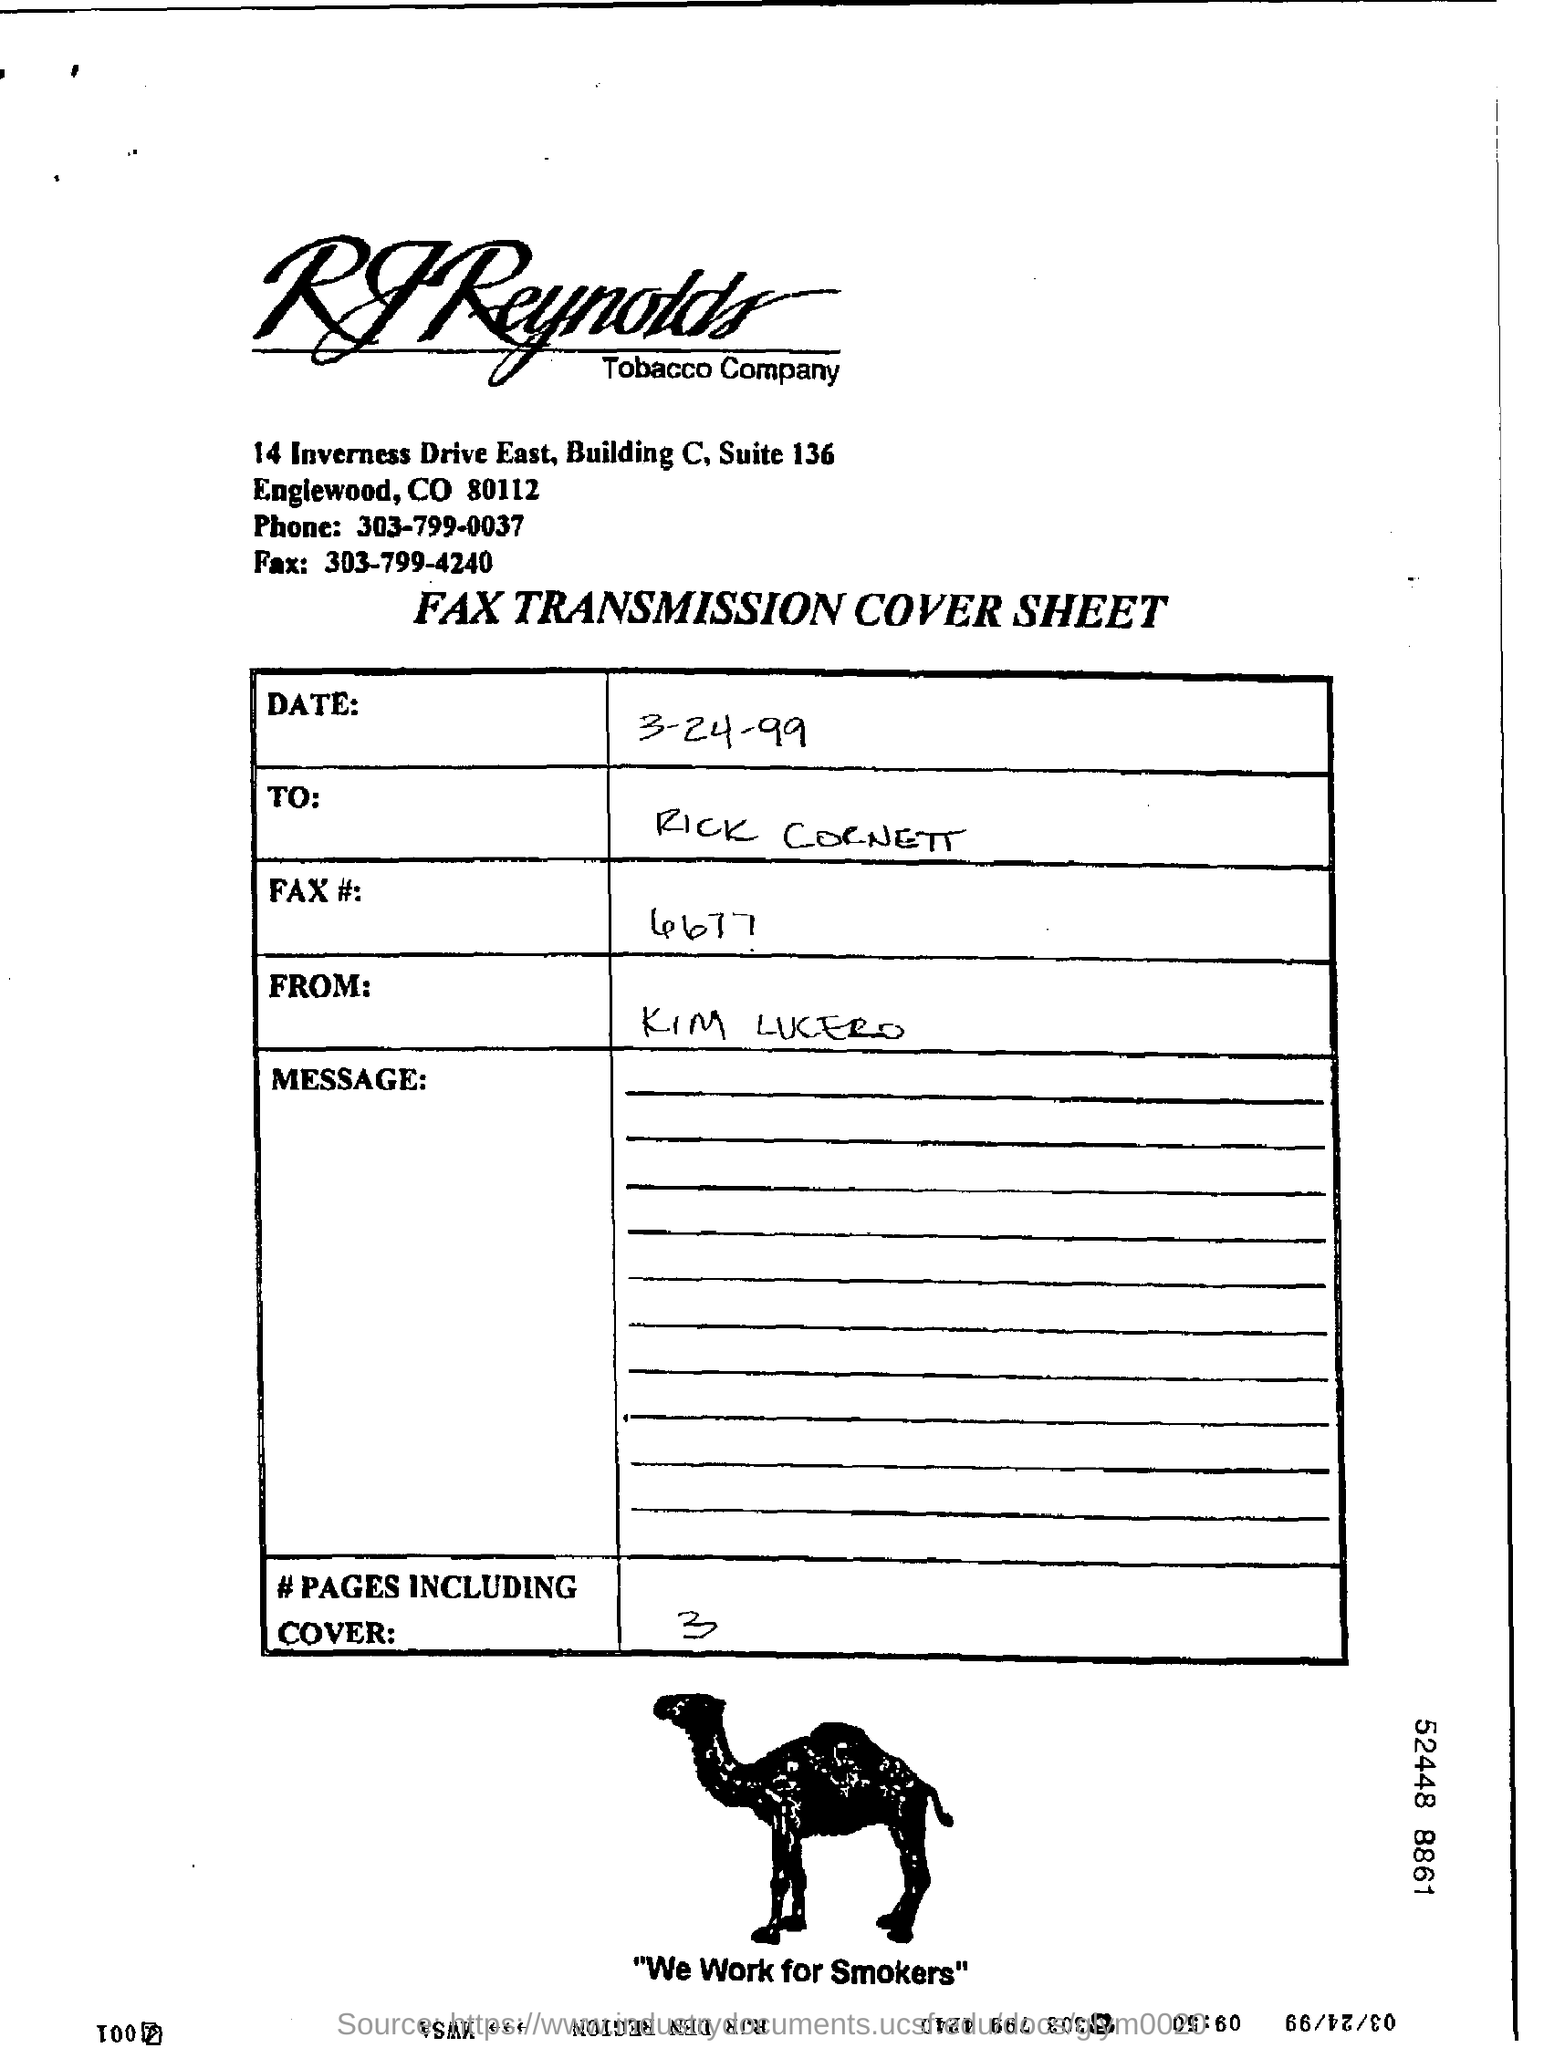To whom the cover sheet is send ?
Your response must be concise. Rick cornett. What is the name of the company ?
Your answer should be compact. RJ Reynolds Tobacco Company. 